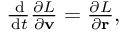<formula> <loc_0><loc_0><loc_500><loc_500>\begin{array} { r } { \frac { \, d } { \, d t } \frac { \partial L } { \partial \mathbf v } = \frac { \partial L } { \partial \mathbf r } , } \end{array}</formula> 